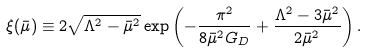<formula> <loc_0><loc_0><loc_500><loc_500>\xi ( \bar { \mu } ) \equiv 2 \sqrt { \Lambda ^ { 2 } - \bar { \mu } ^ { 2 } } \exp \left ( - \frac { \pi ^ { 2 } } { 8 \bar { \mu } ^ { 2 } G _ { D } } + \frac { \Lambda ^ { 2 } - 3 \bar { \mu } ^ { 2 } } { 2 \bar { \mu } ^ { 2 } } \right ) .</formula> 